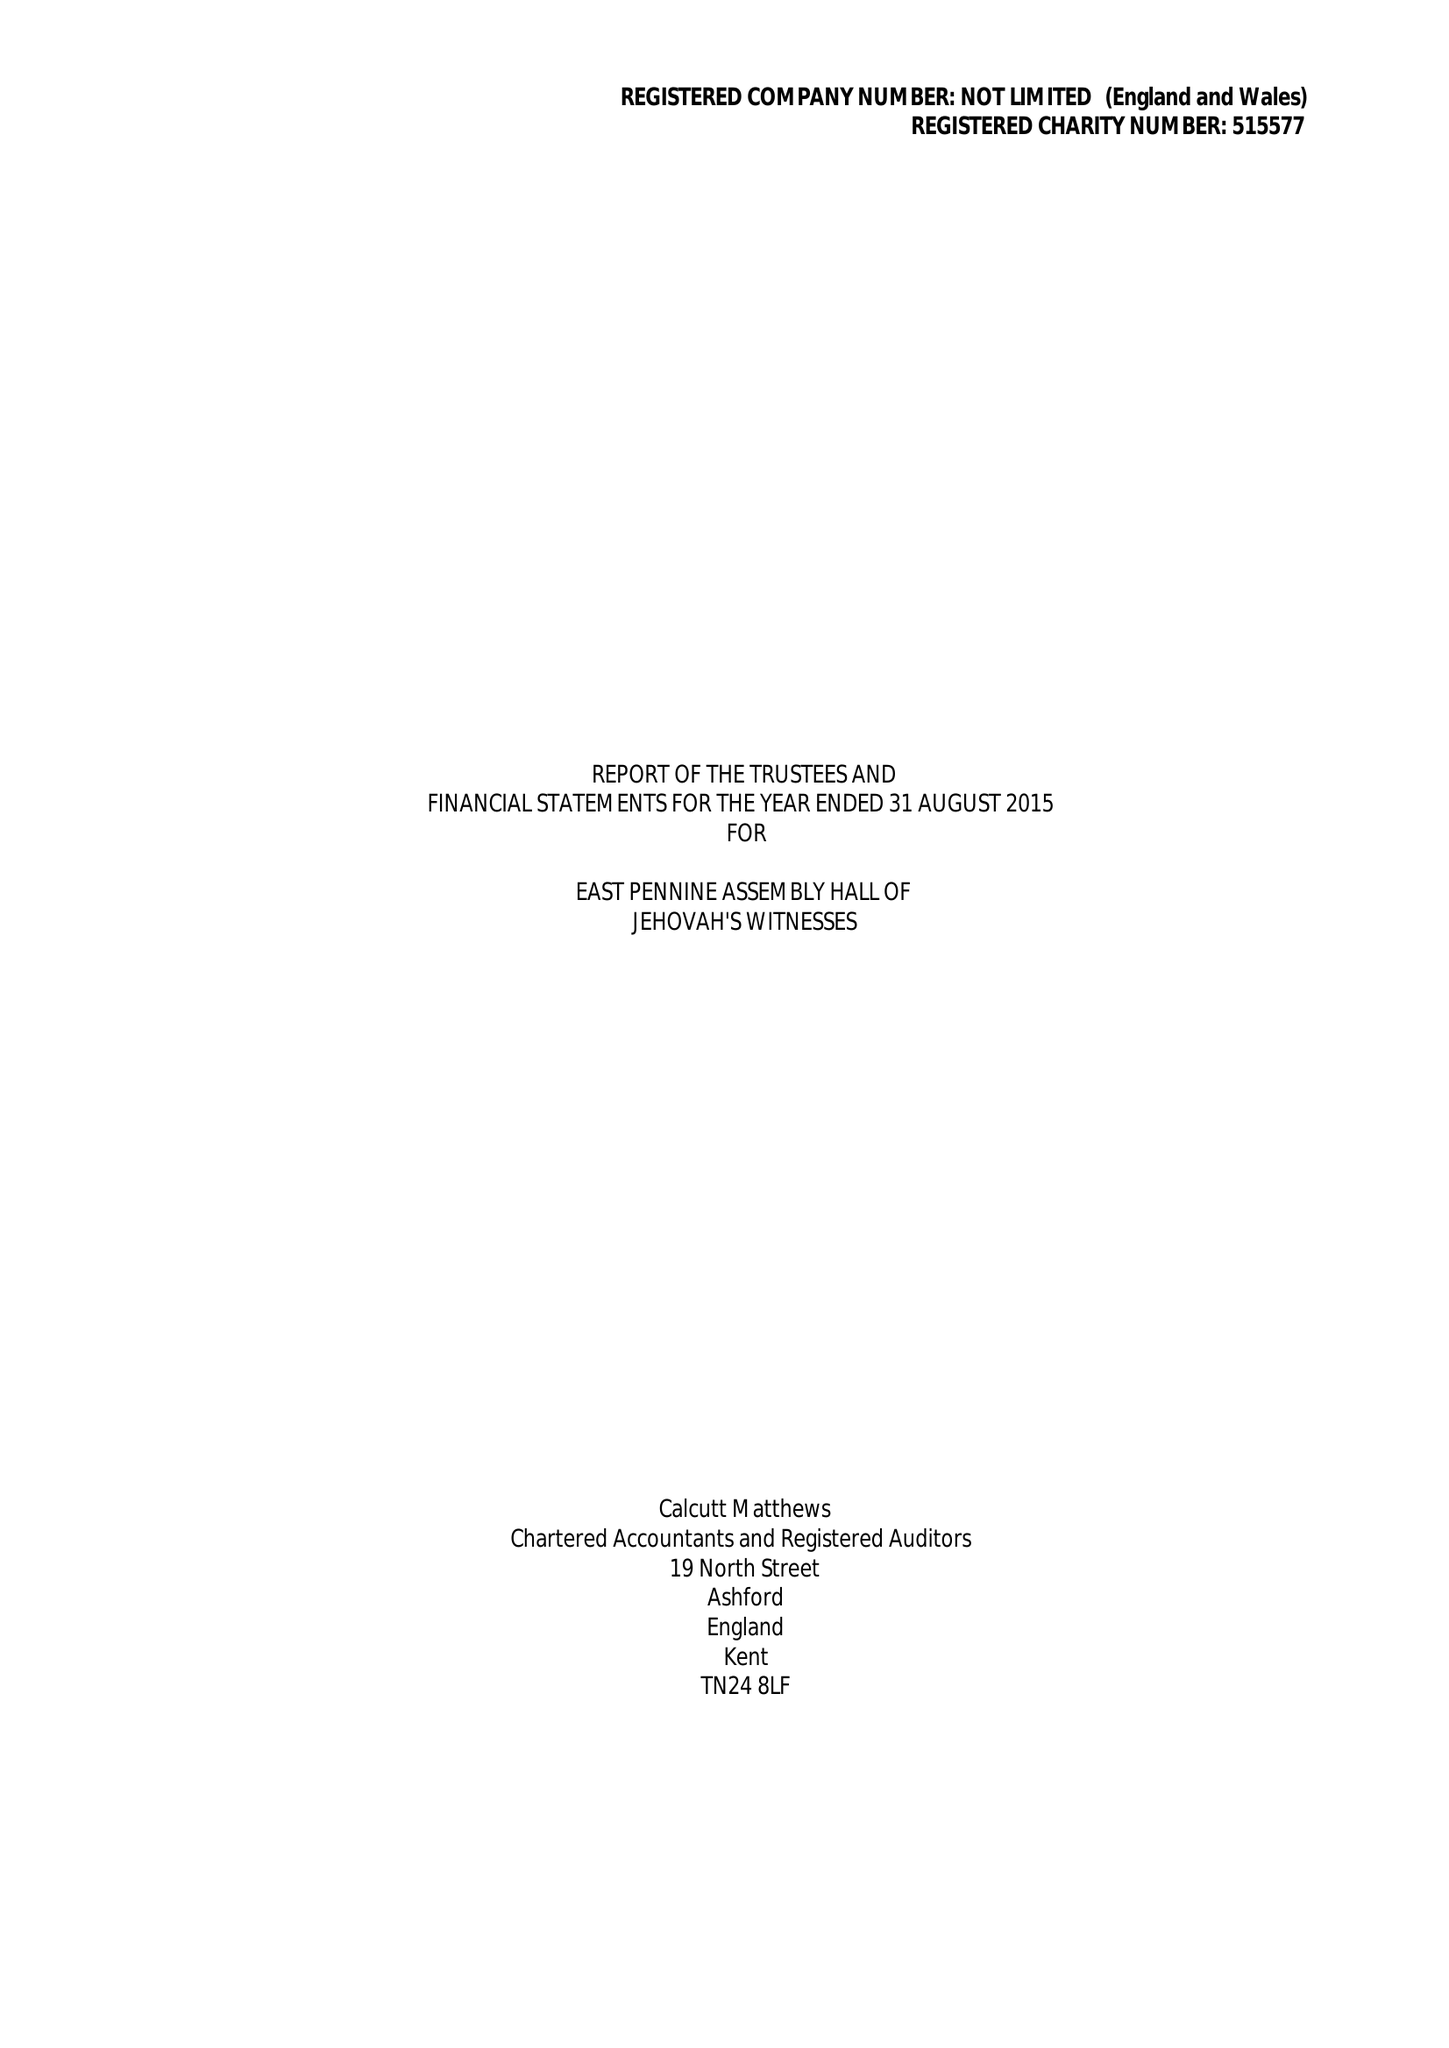What is the value for the address__postcode?
Answer the question using a single word or phrase. S66 8LU 